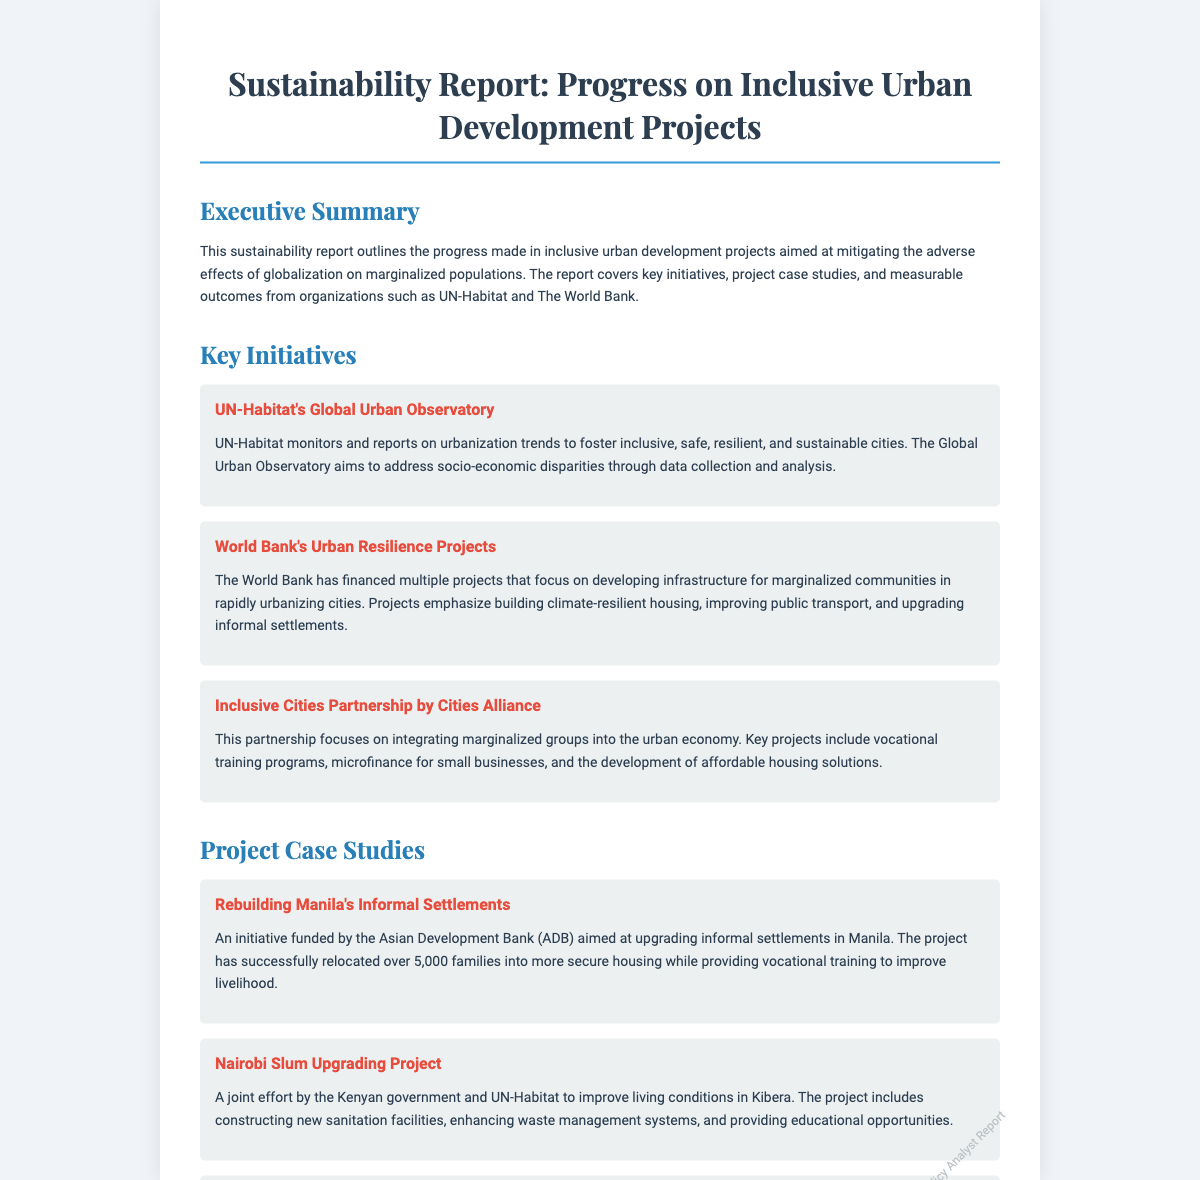What is the title of the report? The title is explicitly stated at the top of the document.
Answer: Sustainability Report: Progress on Inclusive Urban Development Projects Which organization is monitoring urbanization trends? The document mentions UN-Habitat as the organization responsible for this initiative.
Answer: UN-Habitat How many families were relocated in the Manila project? The document provides the number of families relocated as part of the project described under the case studies.
Answer: 5,000 families What percentage increase in access to basic services was achieved? The measurable outcome specifies the percentage of improvement in access to basic services in upgraded informal settlements.
Answer: 25% What is a key focus of the Inclusive Cities Partnership by Cities Alliance? This information is included in the description of the partnership's initiatives in the document.
Answer: Integrating marginalized groups How many residents benefited from the housing project in Dhaka? The document states the number of residents who benefited from this project.
Answer: 10,000 residents What is the objective of the World Bank's Urban Resilience Projects? The document outlines the main objective of the Urban Resilience Projects.
Answer: Developing infrastructure for marginalized communities What will future efforts emphasize? The report highlights the areas that future efforts will prioritize as mentioned in the future directions section.
Answer: Sustainable infrastructure 